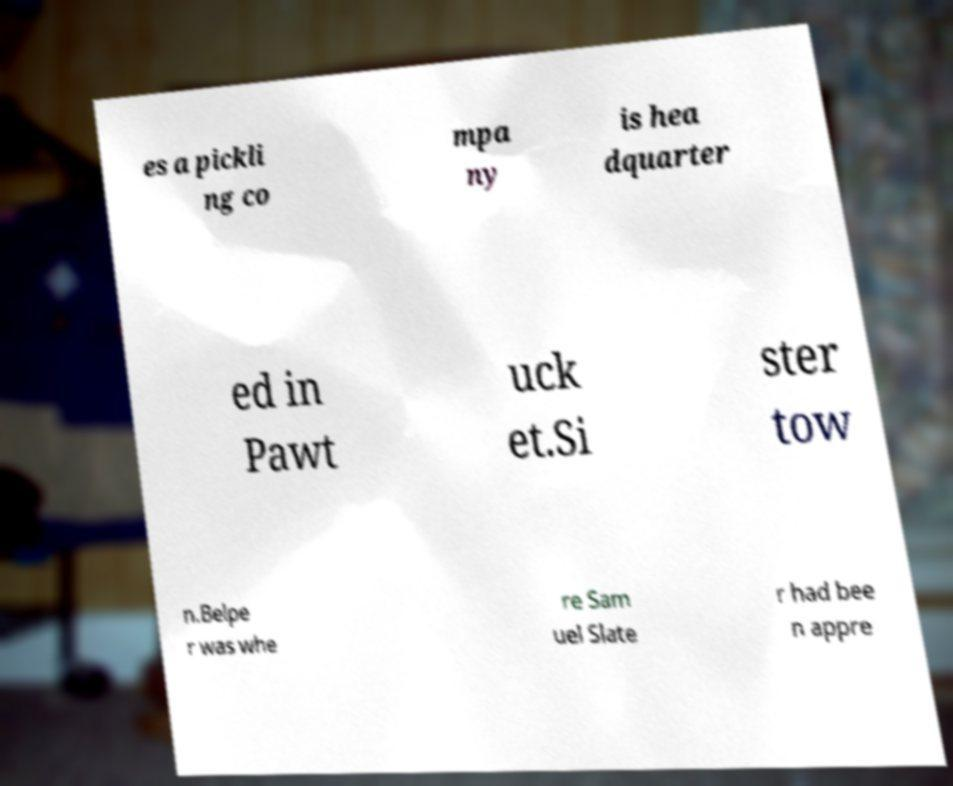Can you accurately transcribe the text from the provided image for me? es a pickli ng co mpa ny is hea dquarter ed in Pawt uck et.Si ster tow n.Belpe r was whe re Sam uel Slate r had bee n appre 